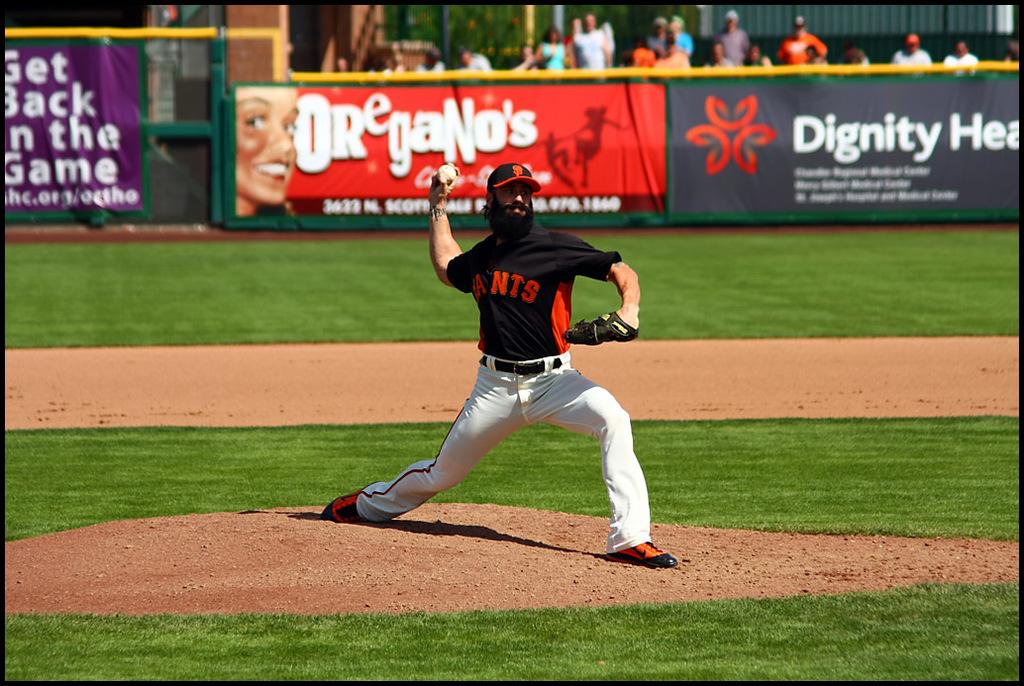What color is the mans shirt?
Provide a succinct answer. Answering does not require reading text in the image. 